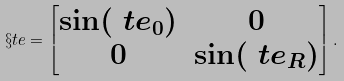Convert formula to latex. <formula><loc_0><loc_0><loc_500><loc_500>\S t e = \begin{bmatrix} \sin ( \ t e _ { 0 } ) & 0 \\ 0 & \sin ( \ t e _ { R } ) \end{bmatrix} .</formula> 